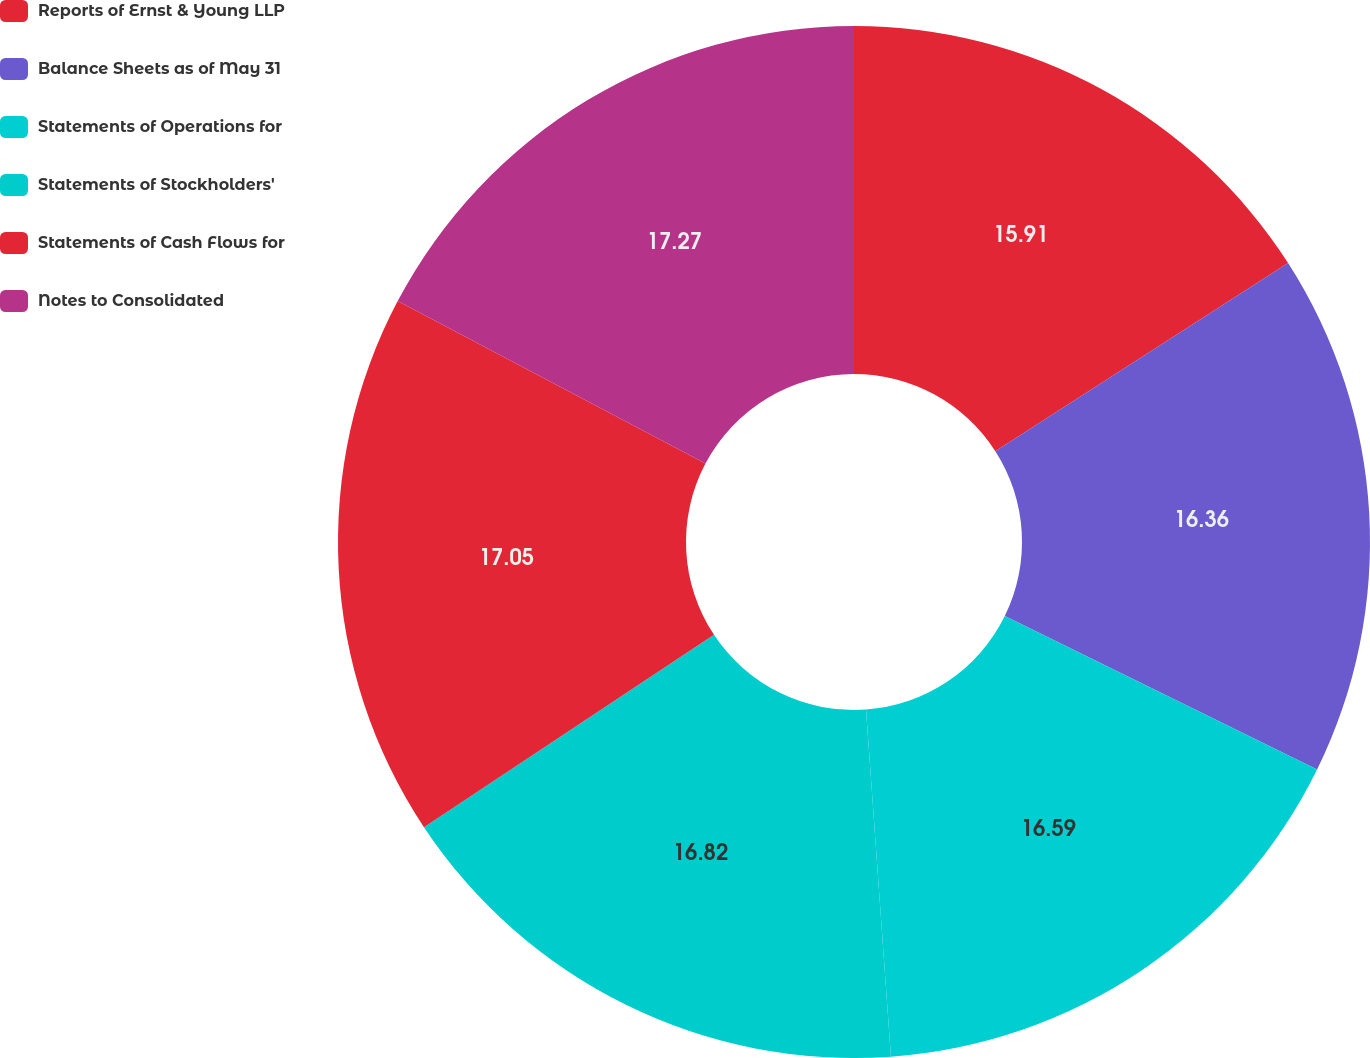Convert chart. <chart><loc_0><loc_0><loc_500><loc_500><pie_chart><fcel>Reports of Ernst & Young LLP<fcel>Balance Sheets as of May 31<fcel>Statements of Operations for<fcel>Statements of Stockholders'<fcel>Statements of Cash Flows for<fcel>Notes to Consolidated<nl><fcel>15.91%<fcel>16.36%<fcel>16.59%<fcel>16.82%<fcel>17.05%<fcel>17.27%<nl></chart> 